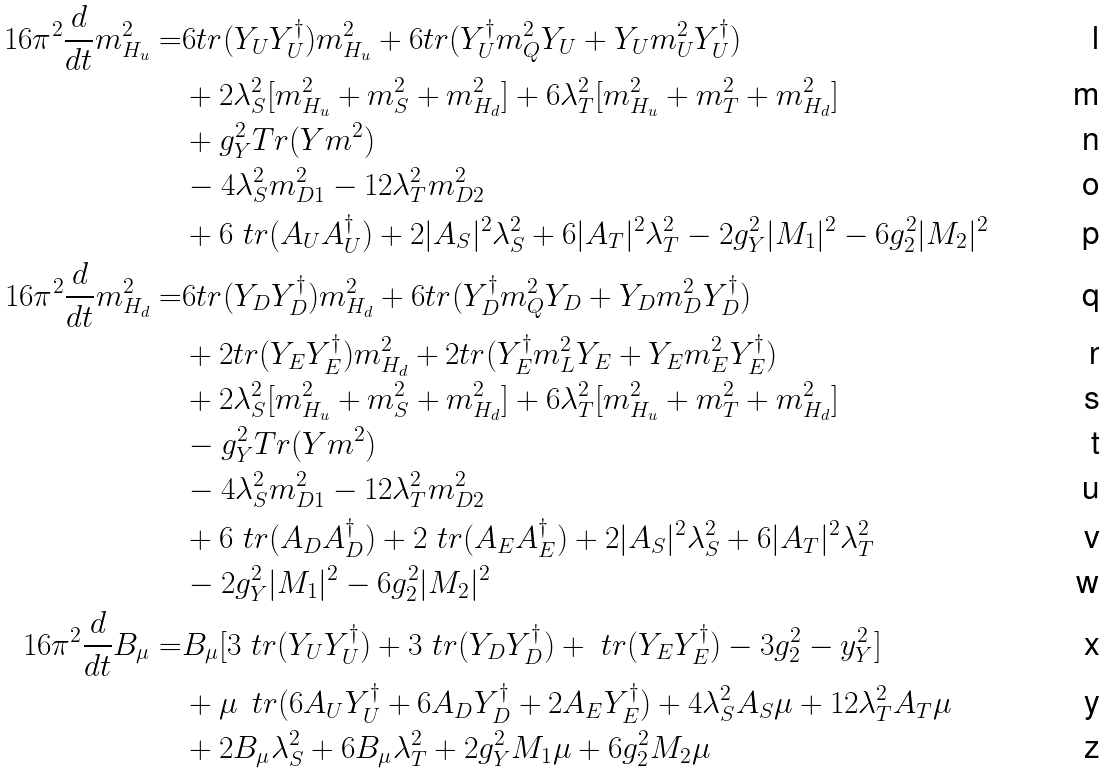<formula> <loc_0><loc_0><loc_500><loc_500>1 6 \pi ^ { 2 } \frac { d } { d t } m ^ { 2 } _ { H _ { u } } = & 6 t r ( Y _ { U } Y _ { U } ^ { \dagger } ) m ^ { 2 } _ { H _ { u } } + 6 t r ( Y _ { U } ^ { \dagger } m ^ { 2 } _ { Q } Y _ { U } + Y _ { U } m _ { U } ^ { 2 } Y _ { U } ^ { \dagger } ) \\ & + 2 \lambda _ { S } ^ { 2 } [ m ^ { 2 } _ { H _ { u } } + m ^ { 2 } _ { S } + m ^ { 2 } _ { H _ { d } } ] + 6 \lambda _ { T } ^ { 2 } [ m ^ { 2 } _ { H _ { u } } + m ^ { 2 } _ { T } + m ^ { 2 } _ { H _ { d } } ] \\ & + g _ { Y } ^ { 2 } T r ( Y m ^ { 2 } ) \\ & - 4 \lambda _ { S } ^ { 2 } m _ { D 1 } ^ { 2 } - 1 2 \lambda _ { T } ^ { 2 } m _ { D 2 } ^ { 2 } \\ & + 6 \ t r ( A _ { U } A _ { U } ^ { \dagger } ) + 2 | A _ { S } | ^ { 2 } \lambda _ { S } ^ { 2 } + 6 | A _ { T } | ^ { 2 } \lambda _ { T } ^ { 2 } - 2 g _ { Y } ^ { 2 } | M _ { 1 } | ^ { 2 } - 6 g _ { 2 } ^ { 2 } | M _ { 2 } | ^ { 2 } \\ 1 6 \pi ^ { 2 } \frac { d } { d t } m ^ { 2 } _ { H _ { d } } = & 6 t r ( Y _ { D } Y _ { D } ^ { \dagger } ) m ^ { 2 } _ { H _ { d } } + 6 t r ( Y _ { D } ^ { \dagger } m ^ { 2 } _ { Q } Y _ { D } + Y _ { D } m ^ { 2 } _ { D } Y _ { D } ^ { \dagger } ) \\ & + 2 t r ( Y _ { E } Y _ { E } ^ { \dagger } ) m ^ { 2 } _ { H _ { d } } + 2 t r ( Y _ { E } ^ { \dagger } m ^ { 2 } _ { L } Y _ { E } + Y _ { E } m ^ { 2 } _ { E } Y _ { E } ^ { \dagger } ) \\ & + 2 \lambda _ { S } ^ { 2 } [ m ^ { 2 } _ { H _ { u } } + m ^ { 2 } _ { S } + m ^ { 2 } _ { H _ { d } } ] + 6 \lambda _ { T } ^ { 2 } [ m ^ { 2 } _ { H _ { u } } + m ^ { 2 } _ { T } + m ^ { 2 } _ { H _ { d } } ] \\ & - g _ { Y } ^ { 2 } T r ( Y m ^ { 2 } ) \\ & - 4 \lambda _ { S } ^ { 2 } m _ { D 1 } ^ { 2 } - 1 2 \lambda _ { T } ^ { 2 } m _ { D 2 } ^ { 2 } \\ & + 6 \ t r ( A _ { D } A _ { D } ^ { \dagger } ) + 2 \ t r ( A _ { E } A _ { E } ^ { \dagger } ) + 2 | A _ { S } | ^ { 2 } \lambda _ { S } ^ { 2 } + 6 | A _ { T } | ^ { 2 } \lambda _ { T } ^ { 2 } \\ & - 2 g _ { Y } ^ { 2 } | M _ { 1 } | ^ { 2 } - 6 g _ { 2 } ^ { 2 } | M _ { 2 } | ^ { 2 } \\ 1 6 \pi ^ { 2 } \frac { d } { d t } B _ { \mu } = & B _ { \mu } [ 3 \ t r ( Y _ { U } Y _ { U } ^ { \dagger } ) + 3 \ t r ( Y _ { D } Y _ { D } ^ { \dagger } ) + \ t r ( Y _ { E } Y _ { E } ^ { \dagger } ) - 3 g _ { 2 } ^ { 2 } - y _ { Y } ^ { 2 } ] \\ & + \mu \, \ t r ( 6 A _ { U } Y _ { U } ^ { \dagger } + 6 A _ { D } Y _ { D } ^ { \dagger } + 2 A _ { E } Y _ { E } ^ { \dagger } ) + 4 \lambda _ { S } ^ { 2 } A _ { S } \mu + 1 2 \lambda _ { T } ^ { 2 } A _ { T } \mu \\ & + 2 B _ { \mu } \lambda _ { S } ^ { 2 } + 6 B _ { \mu } \lambda _ { T } ^ { 2 } + 2 g _ { Y } ^ { 2 } M _ { 1 } \mu + 6 g _ { 2 } ^ { 2 } M _ { 2 } \mu</formula> 